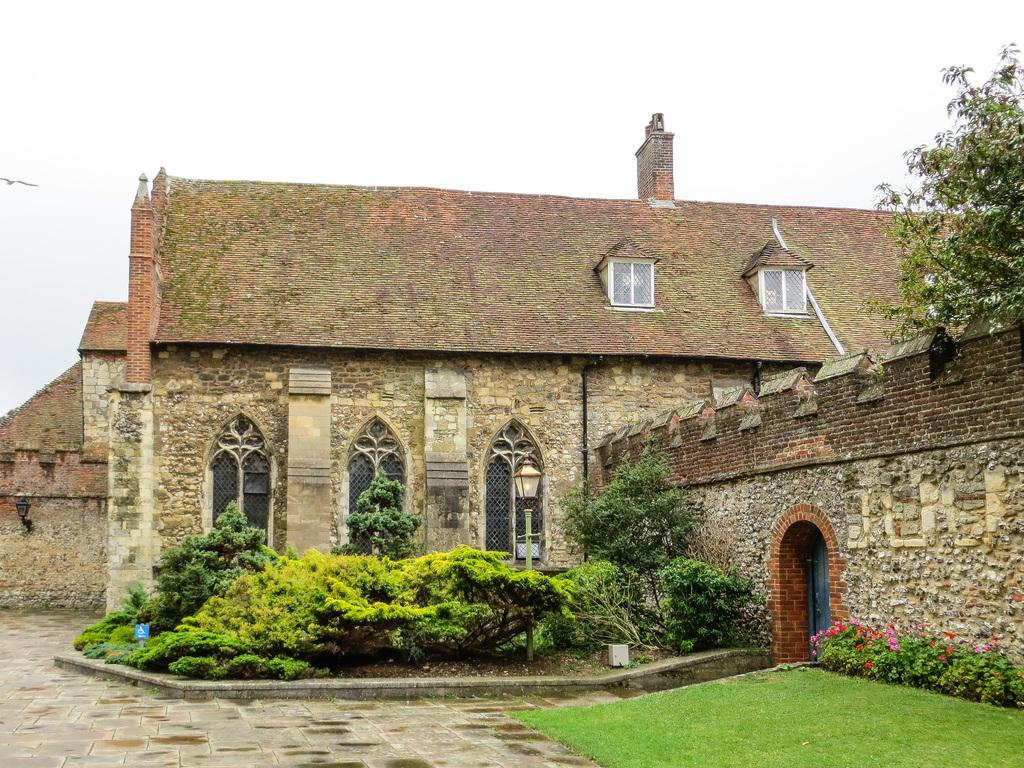What type of structure is present in the image? There is a building in the image. What features can be seen on the building? The building has windows and a door. What type of vegetation is visible in the image? There are trees, grass, and flowers in the image. Can you describe the sky in the background of the image? There is a bird flying in the sky in the background of the image. What type of steam is coming out of the building in the image? There is no steam coming out of the building in the image. What type of war is depicted in the image? There is no war depicted in the image; it features a building, vegetation, and a bird flying in the sky. 